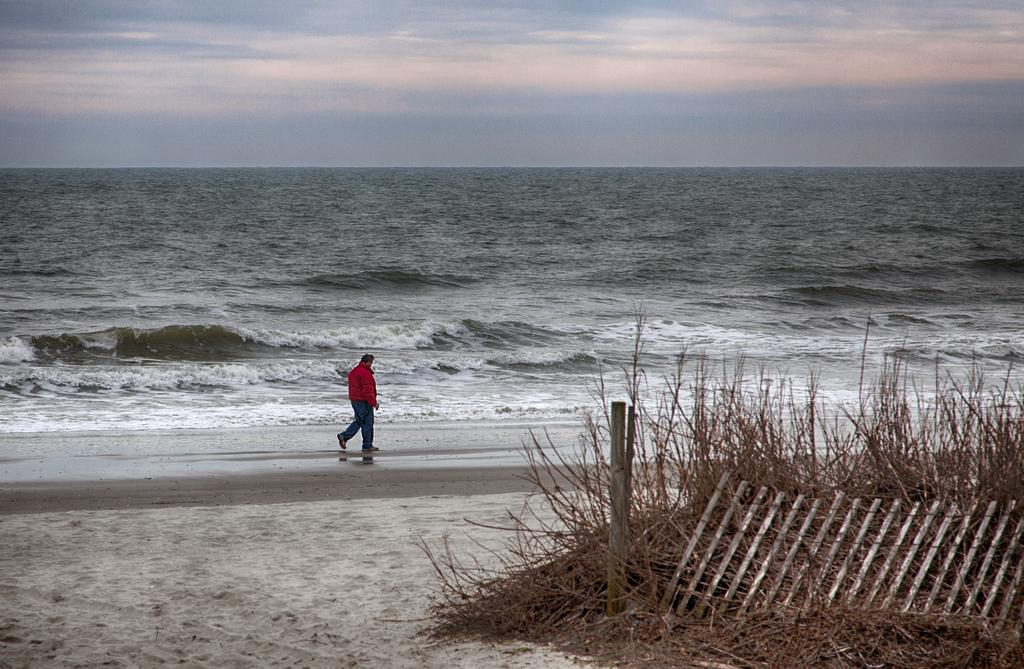What is the person in the image doing? The person is walking in the image. Where is the person walking? The person is at the sea shore. What type of terrain is visible at the bottom of the image? There is sand at the bottom of the image, along with wooden sticks and twigs. What can be seen in the background of the image? The sea and the sky are visible in the background of the image. What type of line is being used to measure the distance between the person and the sea in the image? There is no line present in the image to measure the distance between the person and the sea. 